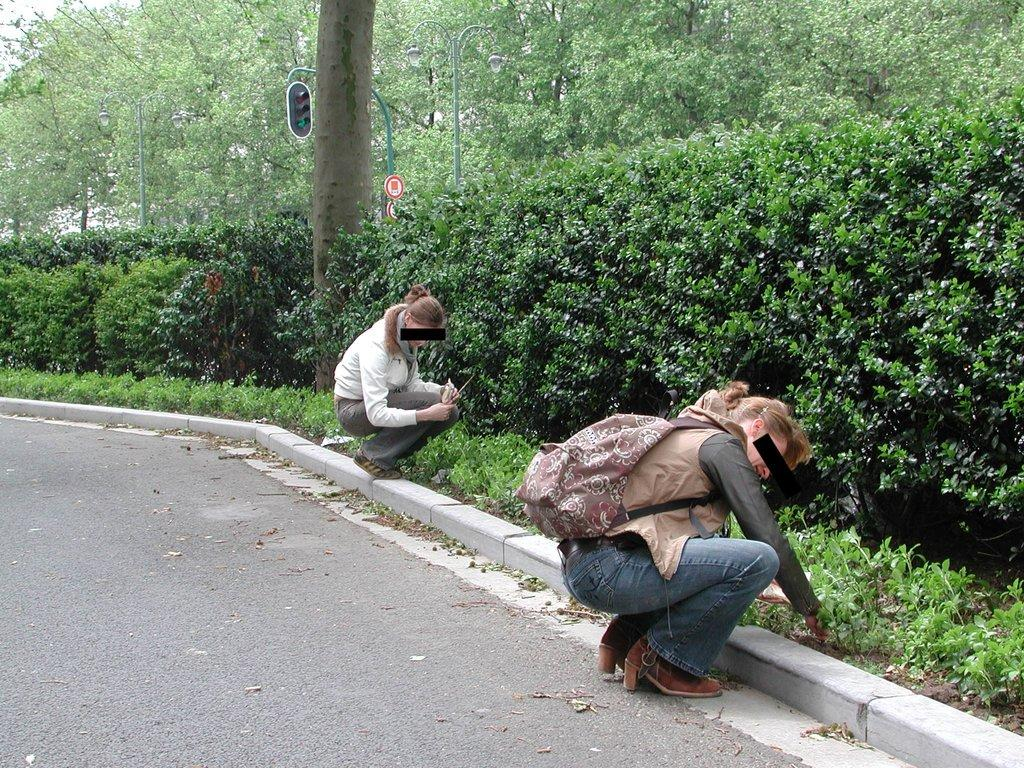How many women are in the image? There are two women in the image. What is located at the bottom of the image? There is a road at the bottom of the image. What type of vegetation is on the right side of the image? There are plants and trees on the right side of the image. What is the purpose of the signal light in the image? The signal light on a pole in the image is used for traffic control. What type of clover is growing on the road in the image? There is no clover visible in the image; the road is clear of any vegetation. 